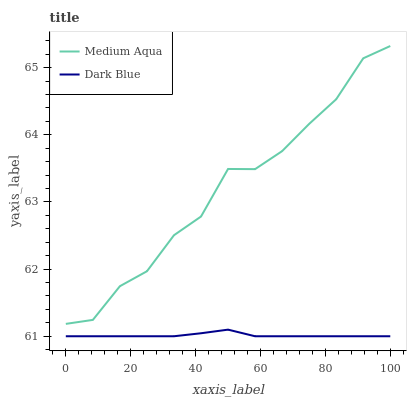Does Dark Blue have the minimum area under the curve?
Answer yes or no. Yes. Does Medium Aqua have the maximum area under the curve?
Answer yes or no. Yes. Does Medium Aqua have the minimum area under the curve?
Answer yes or no. No. Is Dark Blue the smoothest?
Answer yes or no. Yes. Is Medium Aqua the roughest?
Answer yes or no. Yes. Is Medium Aqua the smoothest?
Answer yes or no. No. Does Dark Blue have the lowest value?
Answer yes or no. Yes. Does Medium Aqua have the lowest value?
Answer yes or no. No. Does Medium Aqua have the highest value?
Answer yes or no. Yes. Is Dark Blue less than Medium Aqua?
Answer yes or no. Yes. Is Medium Aqua greater than Dark Blue?
Answer yes or no. Yes. Does Dark Blue intersect Medium Aqua?
Answer yes or no. No. 